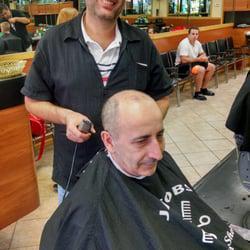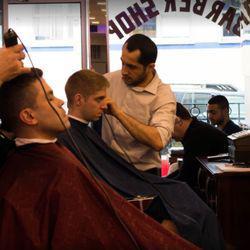The first image is the image on the left, the second image is the image on the right. For the images displayed, is the sentence "There are more people in the barber shop in the right image." factually correct? Answer yes or no. Yes. The first image is the image on the left, the second image is the image on the right. For the images displayed, is the sentence "The right image has only one person giving a haircut, and one person cutting hair." factually correct? Answer yes or no. No. 